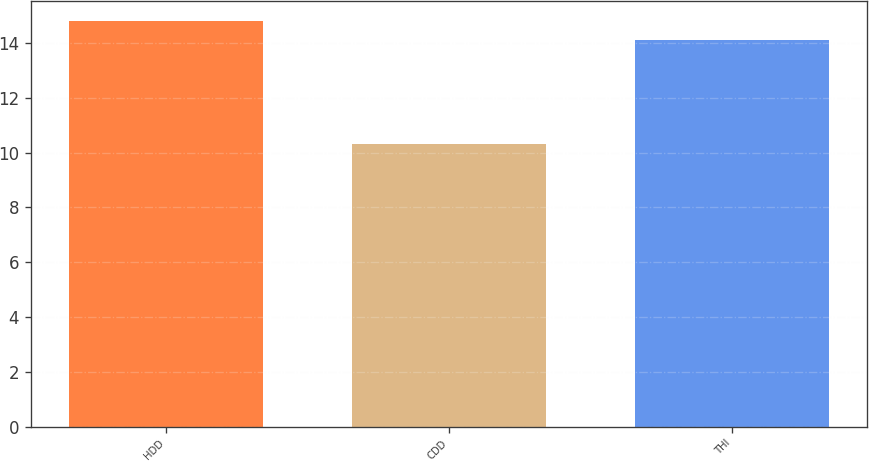Convert chart to OTSL. <chart><loc_0><loc_0><loc_500><loc_500><bar_chart><fcel>HDD<fcel>CDD<fcel>THI<nl><fcel>14.8<fcel>10.3<fcel>14.1<nl></chart> 